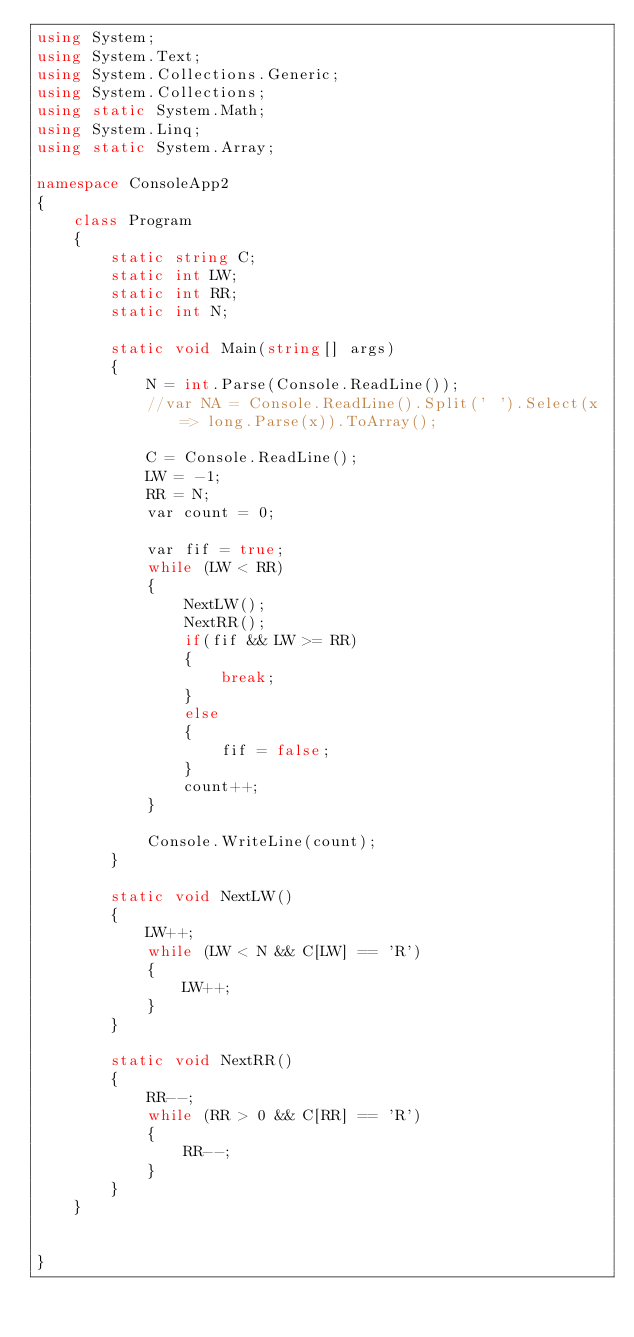<code> <loc_0><loc_0><loc_500><loc_500><_C#_>using System;
using System.Text;
using System.Collections.Generic;
using System.Collections;
using static System.Math;
using System.Linq;
using static System.Array;

namespace ConsoleApp2
{
    class Program
    {
        static string C;
        static int LW;
        static int RR;
        static int N;

        static void Main(string[] args)
        {
            N = int.Parse(Console.ReadLine());
            //var NA = Console.ReadLine().Split(' ').Select(x => long.Parse(x)).ToArray();

            C = Console.ReadLine();
            LW = -1;
            RR = N;
            var count = 0;

            var fif = true;
            while (LW < RR)
            {
                NextLW();
                NextRR();
                if(fif && LW >= RR)
                {
                    break;
                }
                else
                {
                    fif = false;
                }
                count++;
            }

            Console.WriteLine(count);
        }

        static void NextLW()
        {
            LW++;
            while (LW < N && C[LW] == 'R')
            {
                LW++;
            }
        }

        static void NextRR()
        {
            RR--;
            while (RR > 0 && C[RR] == 'R')
            {
                RR--;
            }
        }
    }


}
</code> 